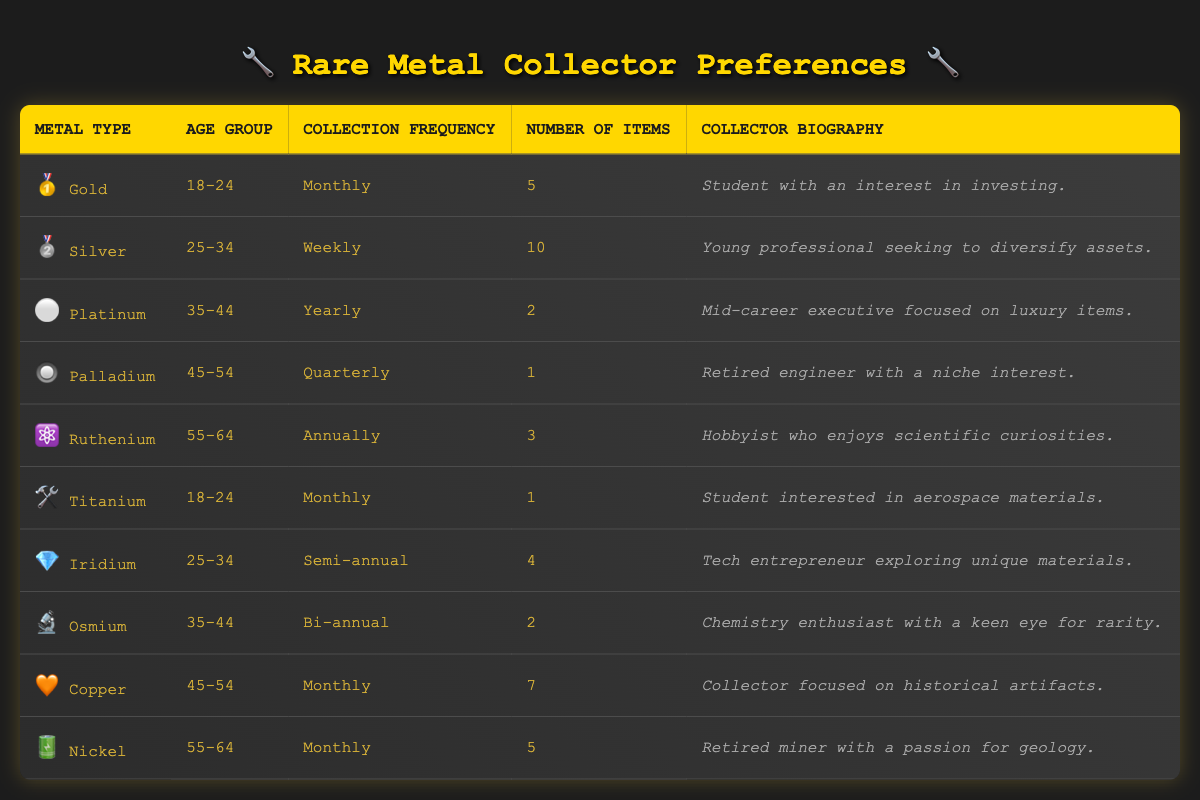What metal type is preferred by collectors aged 18-24? By scanning the table, we can see that there are two metal types listed under the age group 18-24: Gold and Titanium.
Answer: Gold and Titanium How often do collectors of Palladium typically add to their collection? The table specifies that collectors of Palladium in the age group 45-54 have a collection frequency listed as Quarterly.
Answer: Quarterly What is the total number of items collected by individuals who prefer Silver and Copper? From the table, we find that Silver collectors have 10 items and Copper collectors have 7 items. Adding these gives us: 10 + 7 = 17 items in total.
Answer: 17 Is there anyone who collects Ruthenium more than once a year? The collector of Ruthenium in the age group 55-64 has an annual collection frequency, which means they only collect once a year. Therefore, the answer is no.
Answer: No Which age group has the highest number of items collected among the given preferences? We will compare the number of items collected across the different age groups: 18-24 (5+1=6), 25-34 (10+4=14), 35-44 (2+2=4), 45-54 (1+7=8), and 55-64 (3+5=8). The age group 25-34 has the highest total of 14 items.
Answer: 25-34 How many collectors enjoy collecting metals monthly? The table indicates that Gold, Titanium, Copper, and Nickel collectors, aged 18-24, 18-24, 45-54, and 55-64 respectively, collect monthly. This totals to four collectors.
Answer: 4 Is there a collector who focuses on luxury items and also collects Platinum? The table shows that the collector focused on luxury items is associated with Platinum in the age group 35-44. Hence, the answer is yes.
Answer: Yes What is the average number of items collected by individuals in the age group 55-64? For the age group 55-64, there are two collectors: Ruthenium (3 items) and Nickel (5 items). To find the average: (3 + 5) / 2 = 8 / 2 = 4.
Answer: 4 Which metal type has the least number of items collected? Looking at the table, Palladium has the least at 1 item collected, compared to others.
Answer: Palladium 